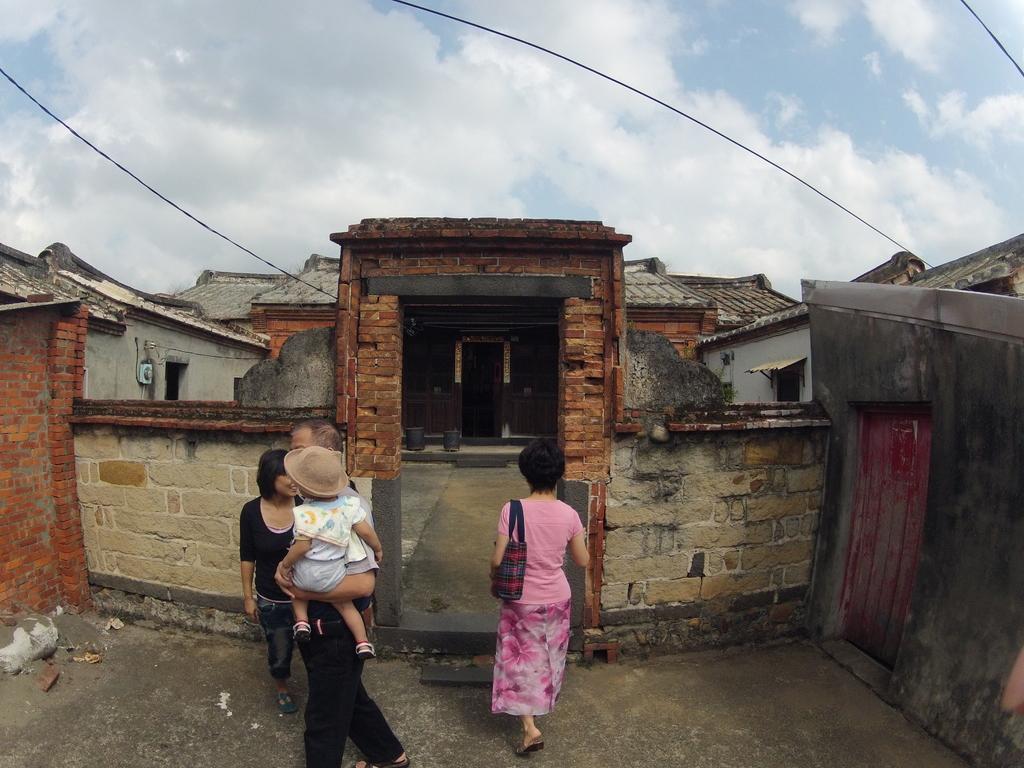Can you describe this image briefly? Here people are standing, this is a house and a sky, these are cables. 